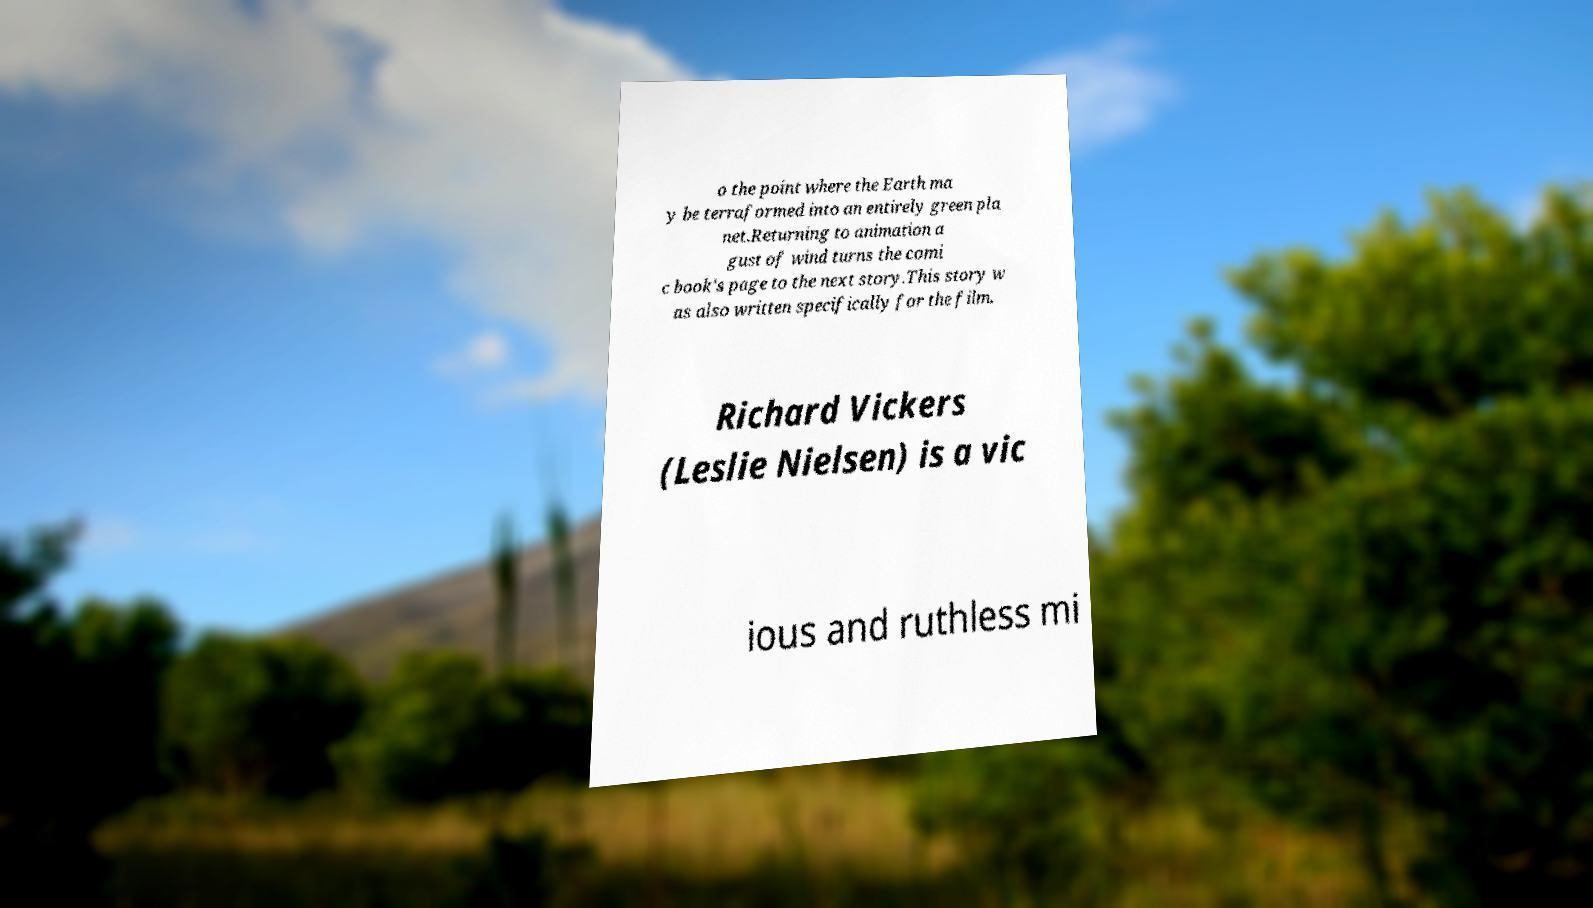I need the written content from this picture converted into text. Can you do that? o the point where the Earth ma y be terraformed into an entirely green pla net.Returning to animation a gust of wind turns the comi c book's page to the next story.This story w as also written specifically for the film. Richard Vickers (Leslie Nielsen) is a vic ious and ruthless mi 